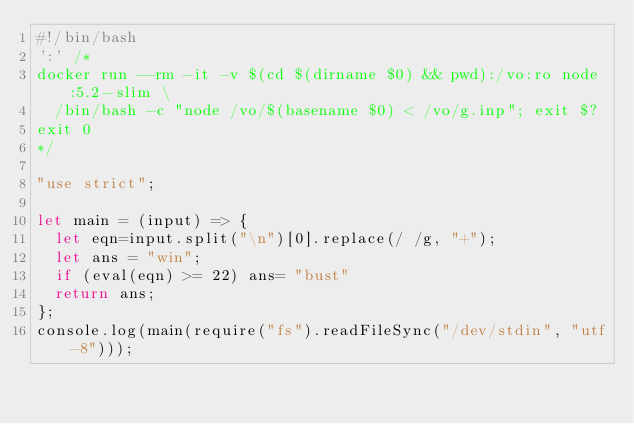Convert code to text. <code><loc_0><loc_0><loc_500><loc_500><_JavaScript_>#!/bin/bash
':' /*
docker run --rm -it -v $(cd $(dirname $0) && pwd):/vo:ro node:5.2-slim \
  /bin/bash -c "node /vo/$(basename $0) < /vo/g.inp"; exit $?
exit 0
*/

"use strict";

let main = (input) => {
  let eqn=input.split("\n")[0].replace(/ /g, "+");
  let ans = "win";
  if (eval(eqn) >= 22) ans= "bust"
  return ans;
};
console.log(main(require("fs").readFileSync("/dev/stdin", "utf-8")));
</code> 